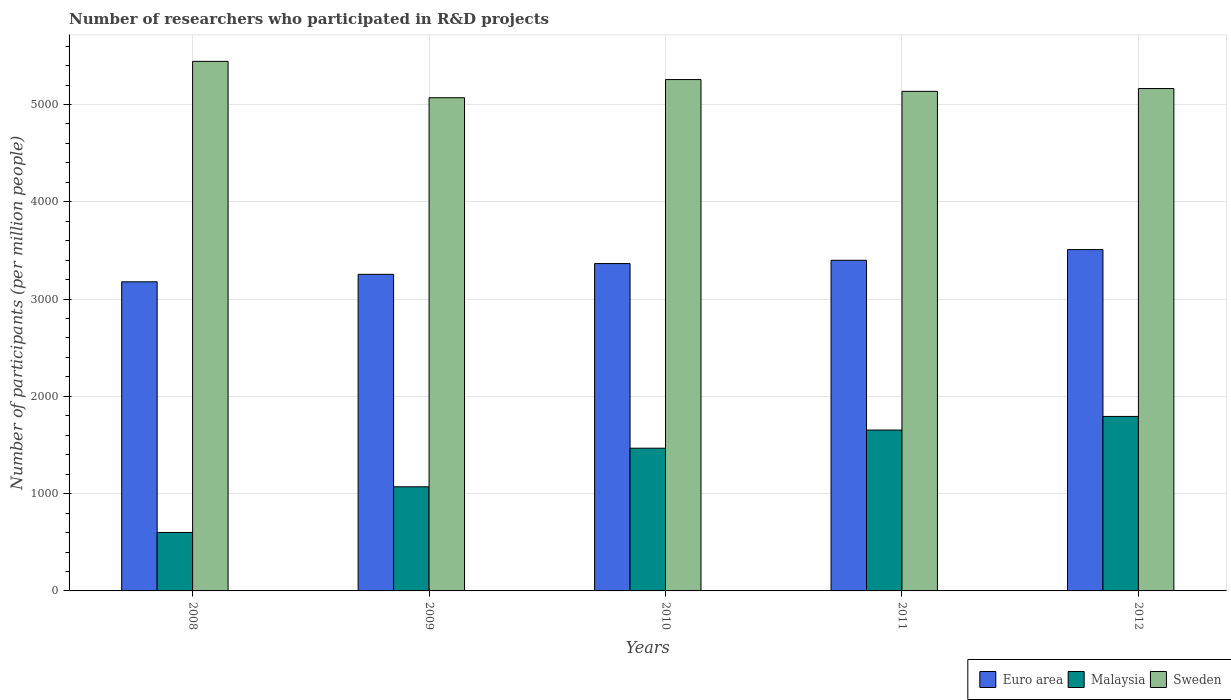How many groups of bars are there?
Your answer should be very brief. 5. Are the number of bars per tick equal to the number of legend labels?
Provide a succinct answer. Yes. How many bars are there on the 4th tick from the left?
Your answer should be very brief. 3. In how many cases, is the number of bars for a given year not equal to the number of legend labels?
Ensure brevity in your answer.  0. What is the number of researchers who participated in R&D projects in Euro area in 2008?
Ensure brevity in your answer.  3177.26. Across all years, what is the maximum number of researchers who participated in R&D projects in Sweden?
Give a very brief answer. 5443.12. Across all years, what is the minimum number of researchers who participated in R&D projects in Euro area?
Ensure brevity in your answer.  3177.26. What is the total number of researchers who participated in R&D projects in Malaysia in the graph?
Your response must be concise. 6585.36. What is the difference between the number of researchers who participated in R&D projects in Sweden in 2010 and that in 2011?
Ensure brevity in your answer.  120.87. What is the difference between the number of researchers who participated in R&D projects in Malaysia in 2008 and the number of researchers who participated in R&D projects in Sweden in 2010?
Offer a very short reply. -4654.9. What is the average number of researchers who participated in R&D projects in Euro area per year?
Your answer should be compact. 3340.55. In the year 2009, what is the difference between the number of researchers who participated in R&D projects in Malaysia and number of researchers who participated in R&D projects in Euro area?
Offer a very short reply. -2183.61. What is the ratio of the number of researchers who participated in R&D projects in Euro area in 2010 to that in 2011?
Your answer should be compact. 0.99. Is the number of researchers who participated in R&D projects in Euro area in 2009 less than that in 2010?
Offer a very short reply. Yes. Is the difference between the number of researchers who participated in R&D projects in Malaysia in 2011 and 2012 greater than the difference between the number of researchers who participated in R&D projects in Euro area in 2011 and 2012?
Your response must be concise. No. What is the difference between the highest and the second highest number of researchers who participated in R&D projects in Malaysia?
Your response must be concise. 140.16. What is the difference between the highest and the lowest number of researchers who participated in R&D projects in Euro area?
Keep it short and to the point. 331.07. What does the 2nd bar from the left in 2010 represents?
Provide a succinct answer. Malaysia. How many bars are there?
Your answer should be compact. 15. Are all the bars in the graph horizontal?
Keep it short and to the point. No. How many years are there in the graph?
Make the answer very short. 5. Are the values on the major ticks of Y-axis written in scientific E-notation?
Make the answer very short. No. Where does the legend appear in the graph?
Make the answer very short. Bottom right. What is the title of the graph?
Make the answer very short. Number of researchers who participated in R&D projects. What is the label or title of the X-axis?
Provide a succinct answer. Years. What is the label or title of the Y-axis?
Your answer should be very brief. Number of participants (per million people). What is the Number of participants (per million people) in Euro area in 2008?
Offer a terse response. 3177.26. What is the Number of participants (per million people) of Malaysia in 2008?
Your response must be concise. 600.96. What is the Number of participants (per million people) in Sweden in 2008?
Provide a short and direct response. 5443.12. What is the Number of participants (per million people) in Euro area in 2009?
Your answer should be compact. 3254. What is the Number of participants (per million people) in Malaysia in 2009?
Your answer should be very brief. 1070.39. What is the Number of participants (per million people) of Sweden in 2009?
Your answer should be compact. 5069.1. What is the Number of participants (per million people) of Euro area in 2010?
Make the answer very short. 3364.79. What is the Number of participants (per million people) in Malaysia in 2010?
Your answer should be very brief. 1467.07. What is the Number of participants (per million people) of Sweden in 2010?
Ensure brevity in your answer.  5255.86. What is the Number of participants (per million people) in Euro area in 2011?
Make the answer very short. 3398.38. What is the Number of participants (per million people) of Malaysia in 2011?
Provide a short and direct response. 1653.38. What is the Number of participants (per million people) in Sweden in 2011?
Your answer should be compact. 5134.98. What is the Number of participants (per million people) in Euro area in 2012?
Your response must be concise. 3508.32. What is the Number of participants (per million people) in Malaysia in 2012?
Keep it short and to the point. 1793.55. What is the Number of participants (per million people) of Sweden in 2012?
Provide a succinct answer. 5163.75. Across all years, what is the maximum Number of participants (per million people) in Euro area?
Give a very brief answer. 3508.32. Across all years, what is the maximum Number of participants (per million people) of Malaysia?
Provide a short and direct response. 1793.55. Across all years, what is the maximum Number of participants (per million people) in Sweden?
Provide a short and direct response. 5443.12. Across all years, what is the minimum Number of participants (per million people) of Euro area?
Offer a terse response. 3177.26. Across all years, what is the minimum Number of participants (per million people) in Malaysia?
Keep it short and to the point. 600.96. Across all years, what is the minimum Number of participants (per million people) in Sweden?
Make the answer very short. 5069.1. What is the total Number of participants (per million people) in Euro area in the graph?
Provide a short and direct response. 1.67e+04. What is the total Number of participants (per million people) in Malaysia in the graph?
Your response must be concise. 6585.36. What is the total Number of participants (per million people) of Sweden in the graph?
Give a very brief answer. 2.61e+04. What is the difference between the Number of participants (per million people) in Euro area in 2008 and that in 2009?
Your answer should be very brief. -76.74. What is the difference between the Number of participants (per million people) of Malaysia in 2008 and that in 2009?
Your answer should be very brief. -469.43. What is the difference between the Number of participants (per million people) in Sweden in 2008 and that in 2009?
Give a very brief answer. 374.02. What is the difference between the Number of participants (per million people) of Euro area in 2008 and that in 2010?
Make the answer very short. -187.54. What is the difference between the Number of participants (per million people) of Malaysia in 2008 and that in 2010?
Keep it short and to the point. -866.11. What is the difference between the Number of participants (per million people) in Sweden in 2008 and that in 2010?
Provide a short and direct response. 187.26. What is the difference between the Number of participants (per million people) in Euro area in 2008 and that in 2011?
Provide a succinct answer. -221.13. What is the difference between the Number of participants (per million people) of Malaysia in 2008 and that in 2011?
Provide a succinct answer. -1052.43. What is the difference between the Number of participants (per million people) of Sweden in 2008 and that in 2011?
Your answer should be compact. 308.13. What is the difference between the Number of participants (per million people) in Euro area in 2008 and that in 2012?
Give a very brief answer. -331.07. What is the difference between the Number of participants (per million people) of Malaysia in 2008 and that in 2012?
Offer a very short reply. -1192.59. What is the difference between the Number of participants (per million people) in Sweden in 2008 and that in 2012?
Provide a succinct answer. 279.37. What is the difference between the Number of participants (per million people) of Euro area in 2009 and that in 2010?
Offer a very short reply. -110.79. What is the difference between the Number of participants (per million people) in Malaysia in 2009 and that in 2010?
Your answer should be compact. -396.68. What is the difference between the Number of participants (per million people) of Sweden in 2009 and that in 2010?
Offer a very short reply. -186.76. What is the difference between the Number of participants (per million people) of Euro area in 2009 and that in 2011?
Keep it short and to the point. -144.38. What is the difference between the Number of participants (per million people) of Malaysia in 2009 and that in 2011?
Your answer should be compact. -582.99. What is the difference between the Number of participants (per million people) in Sweden in 2009 and that in 2011?
Make the answer very short. -65.88. What is the difference between the Number of participants (per million people) in Euro area in 2009 and that in 2012?
Offer a terse response. -254.32. What is the difference between the Number of participants (per million people) of Malaysia in 2009 and that in 2012?
Provide a short and direct response. -723.15. What is the difference between the Number of participants (per million people) in Sweden in 2009 and that in 2012?
Keep it short and to the point. -94.65. What is the difference between the Number of participants (per million people) in Euro area in 2010 and that in 2011?
Your answer should be compact. -33.59. What is the difference between the Number of participants (per million people) of Malaysia in 2010 and that in 2011?
Your answer should be compact. -186.31. What is the difference between the Number of participants (per million people) of Sweden in 2010 and that in 2011?
Your response must be concise. 120.87. What is the difference between the Number of participants (per million people) in Euro area in 2010 and that in 2012?
Make the answer very short. -143.53. What is the difference between the Number of participants (per million people) in Malaysia in 2010 and that in 2012?
Your answer should be compact. -326.47. What is the difference between the Number of participants (per million people) of Sweden in 2010 and that in 2012?
Your answer should be very brief. 92.11. What is the difference between the Number of participants (per million people) of Euro area in 2011 and that in 2012?
Keep it short and to the point. -109.94. What is the difference between the Number of participants (per million people) in Malaysia in 2011 and that in 2012?
Provide a short and direct response. -140.16. What is the difference between the Number of participants (per million people) in Sweden in 2011 and that in 2012?
Offer a very short reply. -28.77. What is the difference between the Number of participants (per million people) in Euro area in 2008 and the Number of participants (per million people) in Malaysia in 2009?
Provide a short and direct response. 2106.86. What is the difference between the Number of participants (per million people) in Euro area in 2008 and the Number of participants (per million people) in Sweden in 2009?
Make the answer very short. -1891.84. What is the difference between the Number of participants (per million people) of Malaysia in 2008 and the Number of participants (per million people) of Sweden in 2009?
Offer a terse response. -4468.14. What is the difference between the Number of participants (per million people) of Euro area in 2008 and the Number of participants (per million people) of Malaysia in 2010?
Offer a very short reply. 1710.18. What is the difference between the Number of participants (per million people) of Euro area in 2008 and the Number of participants (per million people) of Sweden in 2010?
Your response must be concise. -2078.6. What is the difference between the Number of participants (per million people) of Malaysia in 2008 and the Number of participants (per million people) of Sweden in 2010?
Your answer should be very brief. -4654.9. What is the difference between the Number of participants (per million people) of Euro area in 2008 and the Number of participants (per million people) of Malaysia in 2011?
Your answer should be compact. 1523.87. What is the difference between the Number of participants (per million people) in Euro area in 2008 and the Number of participants (per million people) in Sweden in 2011?
Your answer should be compact. -1957.73. What is the difference between the Number of participants (per million people) of Malaysia in 2008 and the Number of participants (per million people) of Sweden in 2011?
Give a very brief answer. -4534.02. What is the difference between the Number of participants (per million people) in Euro area in 2008 and the Number of participants (per million people) in Malaysia in 2012?
Make the answer very short. 1383.71. What is the difference between the Number of participants (per million people) in Euro area in 2008 and the Number of participants (per million people) in Sweden in 2012?
Give a very brief answer. -1986.49. What is the difference between the Number of participants (per million people) of Malaysia in 2008 and the Number of participants (per million people) of Sweden in 2012?
Your answer should be very brief. -4562.79. What is the difference between the Number of participants (per million people) in Euro area in 2009 and the Number of participants (per million people) in Malaysia in 2010?
Your answer should be compact. 1786.93. What is the difference between the Number of participants (per million people) in Euro area in 2009 and the Number of participants (per million people) in Sweden in 2010?
Offer a terse response. -2001.86. What is the difference between the Number of participants (per million people) in Malaysia in 2009 and the Number of participants (per million people) in Sweden in 2010?
Give a very brief answer. -4185.46. What is the difference between the Number of participants (per million people) of Euro area in 2009 and the Number of participants (per million people) of Malaysia in 2011?
Provide a succinct answer. 1600.62. What is the difference between the Number of participants (per million people) in Euro area in 2009 and the Number of participants (per million people) in Sweden in 2011?
Offer a terse response. -1880.98. What is the difference between the Number of participants (per million people) in Malaysia in 2009 and the Number of participants (per million people) in Sweden in 2011?
Offer a very short reply. -4064.59. What is the difference between the Number of participants (per million people) of Euro area in 2009 and the Number of participants (per million people) of Malaysia in 2012?
Make the answer very short. 1460.45. What is the difference between the Number of participants (per million people) in Euro area in 2009 and the Number of participants (per million people) in Sweden in 2012?
Ensure brevity in your answer.  -1909.75. What is the difference between the Number of participants (per million people) in Malaysia in 2009 and the Number of participants (per million people) in Sweden in 2012?
Offer a terse response. -4093.35. What is the difference between the Number of participants (per million people) in Euro area in 2010 and the Number of participants (per million people) in Malaysia in 2011?
Your answer should be very brief. 1711.41. What is the difference between the Number of participants (per million people) in Euro area in 2010 and the Number of participants (per million people) in Sweden in 2011?
Provide a succinct answer. -1770.19. What is the difference between the Number of participants (per million people) in Malaysia in 2010 and the Number of participants (per million people) in Sweden in 2011?
Keep it short and to the point. -3667.91. What is the difference between the Number of participants (per million people) of Euro area in 2010 and the Number of participants (per million people) of Malaysia in 2012?
Provide a succinct answer. 1571.25. What is the difference between the Number of participants (per million people) of Euro area in 2010 and the Number of participants (per million people) of Sweden in 2012?
Your answer should be compact. -1798.95. What is the difference between the Number of participants (per million people) in Malaysia in 2010 and the Number of participants (per million people) in Sweden in 2012?
Keep it short and to the point. -3696.67. What is the difference between the Number of participants (per million people) of Euro area in 2011 and the Number of participants (per million people) of Malaysia in 2012?
Make the answer very short. 1604.83. What is the difference between the Number of participants (per million people) in Euro area in 2011 and the Number of participants (per million people) in Sweden in 2012?
Ensure brevity in your answer.  -1765.37. What is the difference between the Number of participants (per million people) of Malaysia in 2011 and the Number of participants (per million people) of Sweden in 2012?
Give a very brief answer. -3510.36. What is the average Number of participants (per million people) of Euro area per year?
Provide a succinct answer. 3340.55. What is the average Number of participants (per million people) in Malaysia per year?
Provide a short and direct response. 1317.07. What is the average Number of participants (per million people) of Sweden per year?
Provide a short and direct response. 5213.36. In the year 2008, what is the difference between the Number of participants (per million people) in Euro area and Number of participants (per million people) in Malaysia?
Your answer should be compact. 2576.3. In the year 2008, what is the difference between the Number of participants (per million people) of Euro area and Number of participants (per million people) of Sweden?
Provide a short and direct response. -2265.86. In the year 2008, what is the difference between the Number of participants (per million people) in Malaysia and Number of participants (per million people) in Sweden?
Your response must be concise. -4842.16. In the year 2009, what is the difference between the Number of participants (per million people) of Euro area and Number of participants (per million people) of Malaysia?
Ensure brevity in your answer.  2183.61. In the year 2009, what is the difference between the Number of participants (per million people) in Euro area and Number of participants (per million people) in Sweden?
Provide a succinct answer. -1815.1. In the year 2009, what is the difference between the Number of participants (per million people) in Malaysia and Number of participants (per million people) in Sweden?
Give a very brief answer. -3998.7. In the year 2010, what is the difference between the Number of participants (per million people) of Euro area and Number of participants (per million people) of Malaysia?
Your answer should be compact. 1897.72. In the year 2010, what is the difference between the Number of participants (per million people) of Euro area and Number of participants (per million people) of Sweden?
Keep it short and to the point. -1891.06. In the year 2010, what is the difference between the Number of participants (per million people) in Malaysia and Number of participants (per million people) in Sweden?
Your answer should be compact. -3788.78. In the year 2011, what is the difference between the Number of participants (per million people) of Euro area and Number of participants (per million people) of Malaysia?
Your answer should be very brief. 1745. In the year 2011, what is the difference between the Number of participants (per million people) in Euro area and Number of participants (per million people) in Sweden?
Ensure brevity in your answer.  -1736.6. In the year 2011, what is the difference between the Number of participants (per million people) of Malaysia and Number of participants (per million people) of Sweden?
Give a very brief answer. -3481.6. In the year 2012, what is the difference between the Number of participants (per million people) of Euro area and Number of participants (per million people) of Malaysia?
Your response must be concise. 1714.78. In the year 2012, what is the difference between the Number of participants (per million people) in Euro area and Number of participants (per million people) in Sweden?
Your response must be concise. -1655.42. In the year 2012, what is the difference between the Number of participants (per million people) in Malaysia and Number of participants (per million people) in Sweden?
Offer a very short reply. -3370.2. What is the ratio of the Number of participants (per million people) in Euro area in 2008 to that in 2009?
Make the answer very short. 0.98. What is the ratio of the Number of participants (per million people) of Malaysia in 2008 to that in 2009?
Provide a succinct answer. 0.56. What is the ratio of the Number of participants (per million people) in Sweden in 2008 to that in 2009?
Offer a very short reply. 1.07. What is the ratio of the Number of participants (per million people) in Euro area in 2008 to that in 2010?
Your response must be concise. 0.94. What is the ratio of the Number of participants (per million people) of Malaysia in 2008 to that in 2010?
Make the answer very short. 0.41. What is the ratio of the Number of participants (per million people) in Sweden in 2008 to that in 2010?
Provide a short and direct response. 1.04. What is the ratio of the Number of participants (per million people) in Euro area in 2008 to that in 2011?
Provide a short and direct response. 0.93. What is the ratio of the Number of participants (per million people) of Malaysia in 2008 to that in 2011?
Offer a very short reply. 0.36. What is the ratio of the Number of participants (per million people) in Sweden in 2008 to that in 2011?
Offer a very short reply. 1.06. What is the ratio of the Number of participants (per million people) in Euro area in 2008 to that in 2012?
Your response must be concise. 0.91. What is the ratio of the Number of participants (per million people) in Malaysia in 2008 to that in 2012?
Offer a terse response. 0.34. What is the ratio of the Number of participants (per million people) of Sweden in 2008 to that in 2012?
Provide a succinct answer. 1.05. What is the ratio of the Number of participants (per million people) of Euro area in 2009 to that in 2010?
Your answer should be very brief. 0.97. What is the ratio of the Number of participants (per million people) in Malaysia in 2009 to that in 2010?
Keep it short and to the point. 0.73. What is the ratio of the Number of participants (per million people) of Sweden in 2009 to that in 2010?
Ensure brevity in your answer.  0.96. What is the ratio of the Number of participants (per million people) of Euro area in 2009 to that in 2011?
Provide a succinct answer. 0.96. What is the ratio of the Number of participants (per million people) in Malaysia in 2009 to that in 2011?
Provide a short and direct response. 0.65. What is the ratio of the Number of participants (per million people) of Sweden in 2009 to that in 2011?
Ensure brevity in your answer.  0.99. What is the ratio of the Number of participants (per million people) of Euro area in 2009 to that in 2012?
Your response must be concise. 0.93. What is the ratio of the Number of participants (per million people) in Malaysia in 2009 to that in 2012?
Ensure brevity in your answer.  0.6. What is the ratio of the Number of participants (per million people) in Sweden in 2009 to that in 2012?
Ensure brevity in your answer.  0.98. What is the ratio of the Number of participants (per million people) in Malaysia in 2010 to that in 2011?
Your answer should be very brief. 0.89. What is the ratio of the Number of participants (per million people) of Sweden in 2010 to that in 2011?
Provide a short and direct response. 1.02. What is the ratio of the Number of participants (per million people) in Euro area in 2010 to that in 2012?
Give a very brief answer. 0.96. What is the ratio of the Number of participants (per million people) of Malaysia in 2010 to that in 2012?
Provide a succinct answer. 0.82. What is the ratio of the Number of participants (per million people) in Sweden in 2010 to that in 2012?
Make the answer very short. 1.02. What is the ratio of the Number of participants (per million people) in Euro area in 2011 to that in 2012?
Keep it short and to the point. 0.97. What is the ratio of the Number of participants (per million people) in Malaysia in 2011 to that in 2012?
Your answer should be compact. 0.92. What is the ratio of the Number of participants (per million people) of Sweden in 2011 to that in 2012?
Offer a very short reply. 0.99. What is the difference between the highest and the second highest Number of participants (per million people) of Euro area?
Offer a terse response. 109.94. What is the difference between the highest and the second highest Number of participants (per million people) of Malaysia?
Keep it short and to the point. 140.16. What is the difference between the highest and the second highest Number of participants (per million people) in Sweden?
Provide a succinct answer. 187.26. What is the difference between the highest and the lowest Number of participants (per million people) in Euro area?
Provide a succinct answer. 331.07. What is the difference between the highest and the lowest Number of participants (per million people) of Malaysia?
Give a very brief answer. 1192.59. What is the difference between the highest and the lowest Number of participants (per million people) in Sweden?
Your response must be concise. 374.02. 